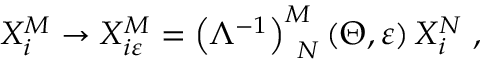<formula> <loc_0><loc_0><loc_500><loc_500>X _ { i } ^ { M } \rightarrow X _ { i \varepsilon } ^ { M } = \left ( \Lambda ^ { - 1 } \right ) _ { \, N } ^ { M } \left ( \Theta , \varepsilon \right ) X _ { i } ^ { N } \, ,</formula> 